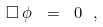<formula> <loc_0><loc_0><loc_500><loc_500>\Box \, \phi \ = \ 0 \ ,</formula> 